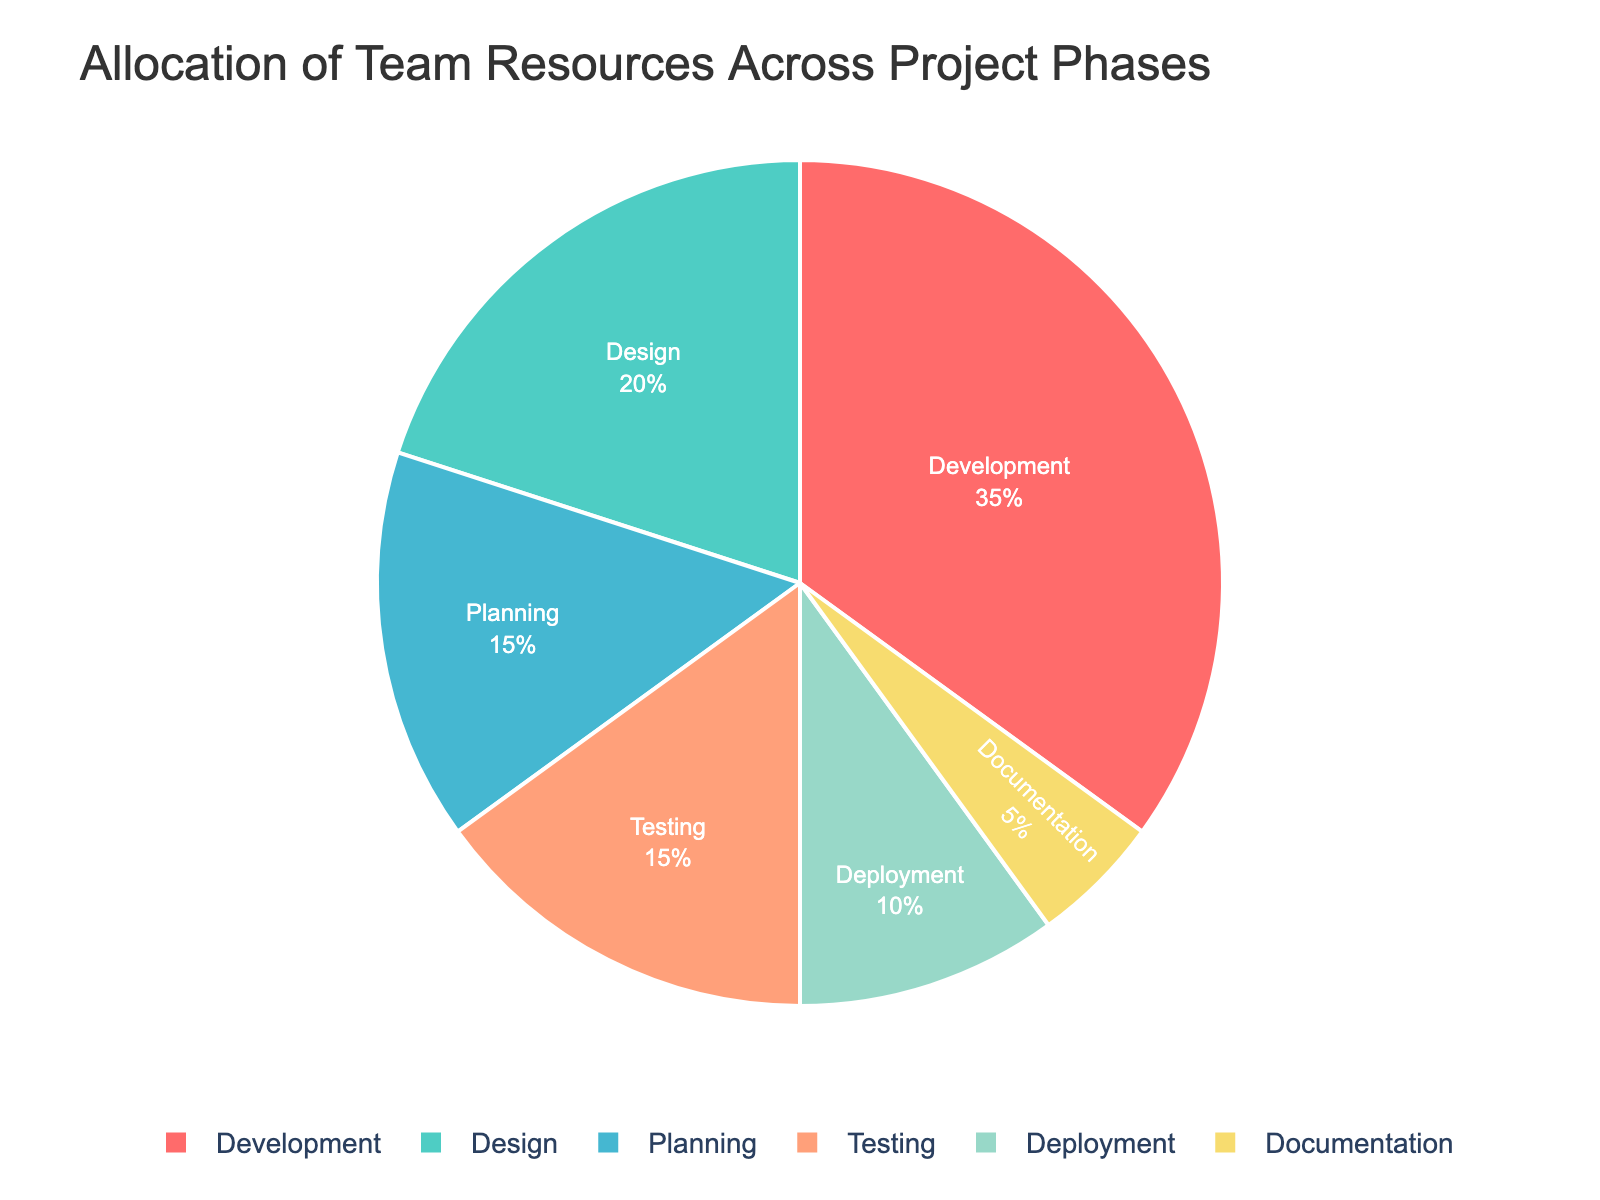What percentage of resources is allocated to Development and Testing phases combined? Summing up the percentage allocations for Development (35%) and Testing (15%) gives 35% + 15% = 50%.
Answer: 50% Which phase allocates the least amount of resources? The Documentation phase has the smallest percentage allocation at 5%.
Answer: Documentation Is the allocation for Design greater than that for Deployment? Comparing the percentages, Design has 20% while Deployment has 10%, so Design's allocation is greater.
Answer: Yes How much more resources are allocated to Development compared to Deployment? The allocation for Development (35%) is 25% more than that for Deployment (10%), calculated as 35% - 10% = 25%.
Answer: 25% Which two phases have equal resource allocation? Both Planning and Testing phases have the same resource allocation of 15%.
Answer: Planning and Testing What is the total resource allocation for phases other than Development? Adding up the percentages for Planning (15%), Design (20%), Testing (15%), Deployment (10%), and Documentation (5%) gives 15% + 20% + 15% + 10% + 5% = 65%.
Answer: 65% How does the resource allocation for Documentation compare to that for Deployment? Documentation (5%) is 5% less than Deployment (10%).
Answer: 5% less Which color represents the Design phase in the pie chart? The color used for the Design phase is green.
Answer: Green What fraction of resources is allocated to Development relative to the total allocation for Planning, Design, and Testing combined? The combined allocation for Planning, Design, and Testing is 15% + 20% + 15% = 50%. The fraction of Development (35%) to this combined value is 35/50 = 0.7 or 70%.
Answer: 70% If the team reallocates 5% from Development to Documentation, what will be the new percentage for Documentation? Initially, Documentation is at 5%, adding 5% from Development makes it 5% + 5% = 10%.
Answer: 10% 